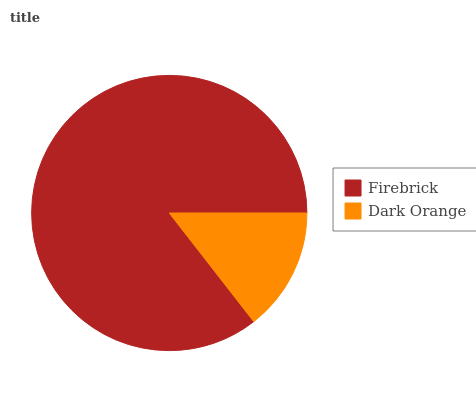Is Dark Orange the minimum?
Answer yes or no. Yes. Is Firebrick the maximum?
Answer yes or no. Yes. Is Dark Orange the maximum?
Answer yes or no. No. Is Firebrick greater than Dark Orange?
Answer yes or no. Yes. Is Dark Orange less than Firebrick?
Answer yes or no. Yes. Is Dark Orange greater than Firebrick?
Answer yes or no. No. Is Firebrick less than Dark Orange?
Answer yes or no. No. Is Firebrick the high median?
Answer yes or no. Yes. Is Dark Orange the low median?
Answer yes or no. Yes. Is Dark Orange the high median?
Answer yes or no. No. Is Firebrick the low median?
Answer yes or no. No. 